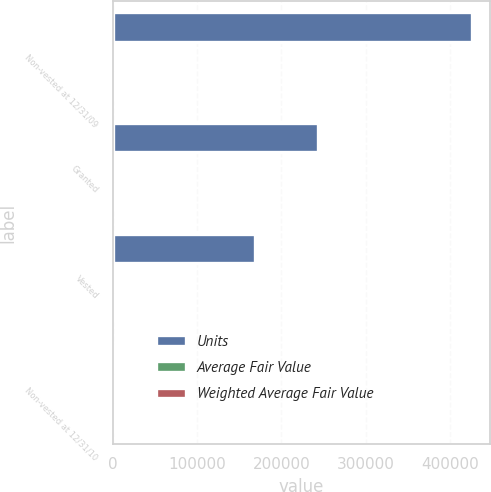<chart> <loc_0><loc_0><loc_500><loc_500><stacked_bar_chart><ecel><fcel>Non-vested at 12/31/09<fcel>Granted<fcel>Vested<fcel>Non-vested at 12/31/10<nl><fcel>Units<fcel>426686<fcel>243750<fcel>168511<fcel>59.31<nl><fcel>Average Fair Value<fcel>54.32<fcel>41.34<fcel>73.03<fcel>59.1<nl><fcel>Weighted Average Fair Value<fcel>54.44<fcel>41.34<fcel>72.87<fcel>59.31<nl></chart> 